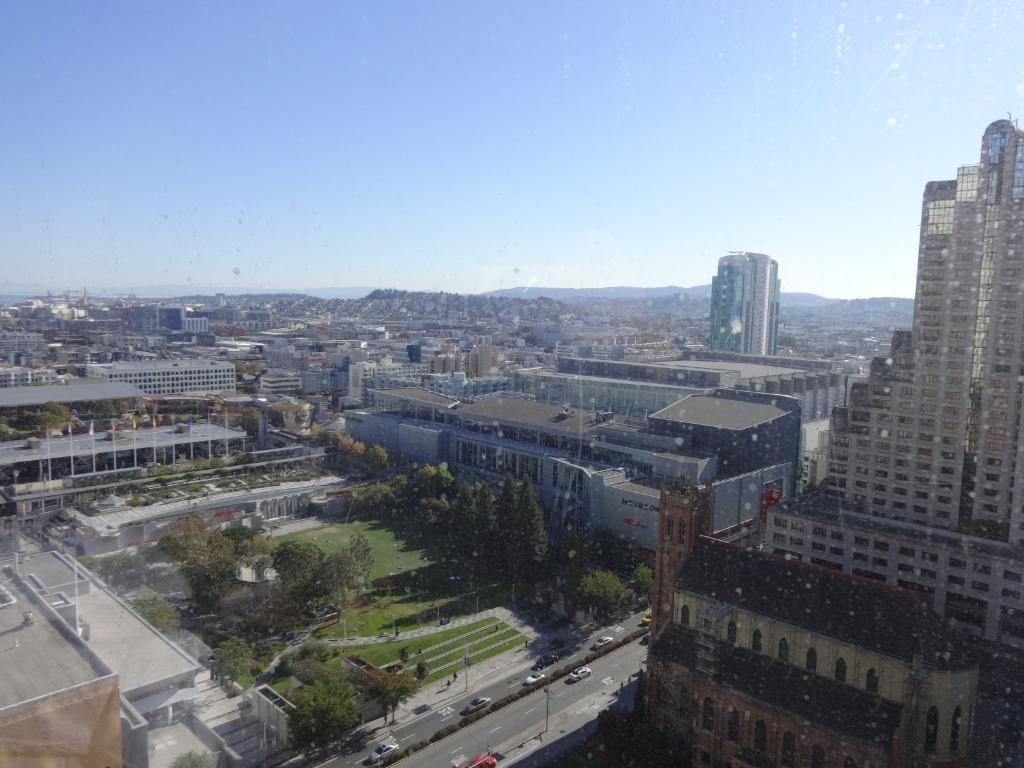What type of location is shown in the image? The image depicts a city. What are some of the prominent features of the city? There are many tall buildings and houses in the city. Can you describe the transportation infrastructure in the city? There is a road in the city. What can be found beside the road? There is a garden beside the road. What kind of vegetation is present in the garden? The garden contains many trees. How does the decision-making process of the clam affect the city's infrastructure? There are no clams present in the image, and therefore their decision-making process cannot affect the city's infrastructure. 